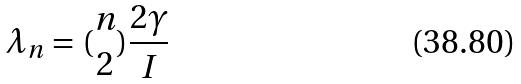Convert formula to latex. <formula><loc_0><loc_0><loc_500><loc_500>\lambda _ { n } = ( \begin{matrix} n \\ 2 \end{matrix} ) \frac { 2 \gamma } { I }</formula> 